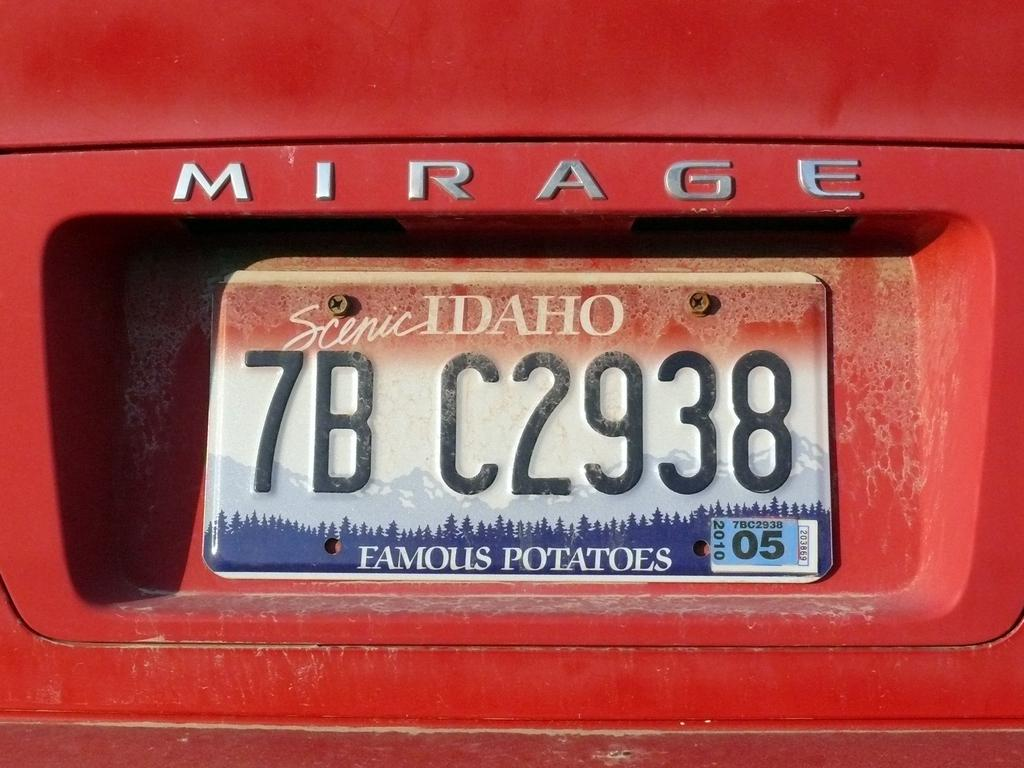<image>
Render a clear and concise summary of the photo. Idaho license plate with the word and numbers 7BC2938. 